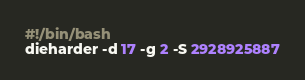Convert code to text. <code><loc_0><loc_0><loc_500><loc_500><_Bash_>#!/bin/bash
dieharder -d 17 -g 2 -S 2928925887
</code> 